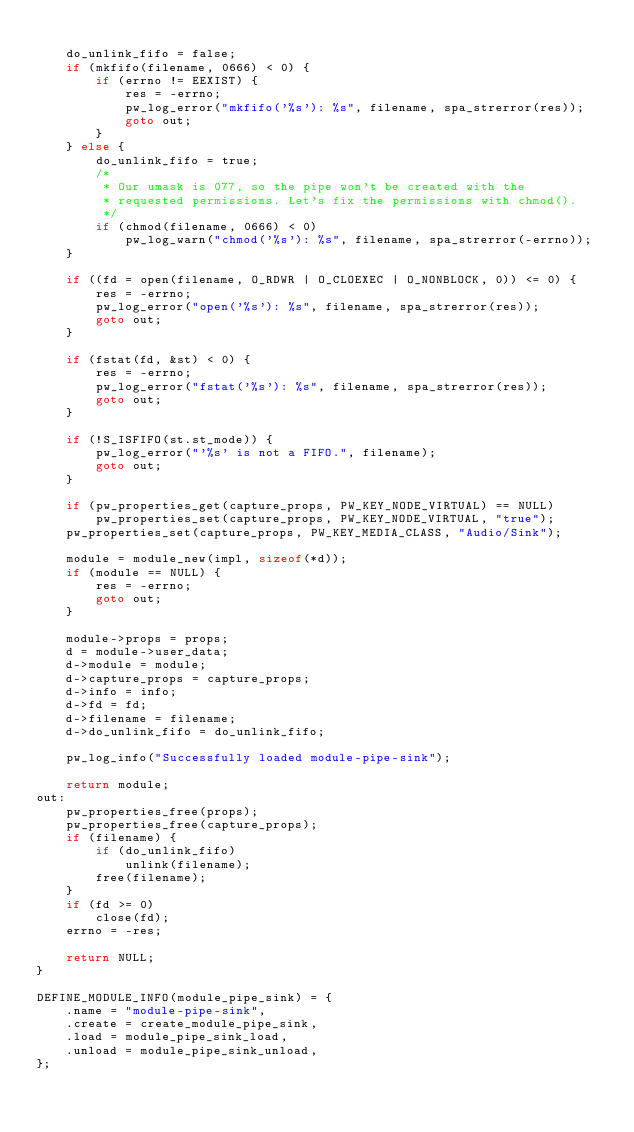Convert code to text. <code><loc_0><loc_0><loc_500><loc_500><_C_>
	do_unlink_fifo = false;
	if (mkfifo(filename, 0666) < 0) {
		if (errno != EEXIST) {
			res = -errno;
			pw_log_error("mkfifo('%s'): %s", filename, spa_strerror(res));
			goto out;
		}
	} else {
		do_unlink_fifo = true;
		/*
		 * Our umask is 077, so the pipe won't be created with the
		 * requested permissions. Let's fix the permissions with chmod().
		 */
		if (chmod(filename, 0666) < 0)
			pw_log_warn("chmod('%s'): %s", filename, spa_strerror(-errno));
	}

	if ((fd = open(filename, O_RDWR | O_CLOEXEC | O_NONBLOCK, 0)) <= 0) {
		res = -errno;
		pw_log_error("open('%s'): %s", filename, spa_strerror(res));
		goto out;
	}

	if (fstat(fd, &st) < 0) {
		res = -errno;
		pw_log_error("fstat('%s'): %s", filename, spa_strerror(res));
		goto out;
	}

	if (!S_ISFIFO(st.st_mode)) {
		pw_log_error("'%s' is not a FIFO.", filename);
		goto out;
	}

	if (pw_properties_get(capture_props, PW_KEY_NODE_VIRTUAL) == NULL)
		pw_properties_set(capture_props, PW_KEY_NODE_VIRTUAL, "true");
	pw_properties_set(capture_props, PW_KEY_MEDIA_CLASS, "Audio/Sink");

	module = module_new(impl, sizeof(*d));
	if (module == NULL) {
		res = -errno;
		goto out;
	}

	module->props = props;
	d = module->user_data;
	d->module = module;
	d->capture_props = capture_props;
	d->info = info;
	d->fd = fd;
	d->filename = filename;
	d->do_unlink_fifo = do_unlink_fifo;

	pw_log_info("Successfully loaded module-pipe-sink");

	return module;
out:
	pw_properties_free(props);
	pw_properties_free(capture_props);
	if (filename) {
		if (do_unlink_fifo)
			unlink(filename);
		free(filename);
	}
	if (fd >= 0)
		close(fd);
	errno = -res;

	return NULL;
}

DEFINE_MODULE_INFO(module_pipe_sink) = {
	.name = "module-pipe-sink",
	.create = create_module_pipe_sink,
	.load = module_pipe_sink_load,
	.unload = module_pipe_sink_unload,
};
</code> 